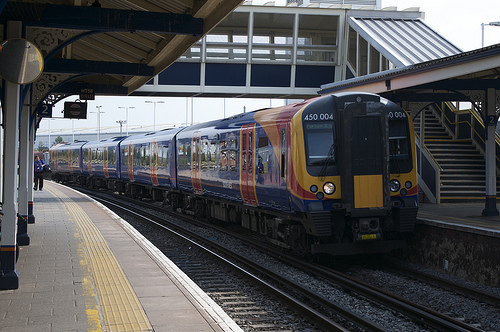What is the function of the structure seen at coordinates [0.3, 0.18, 0.88, 0.36]? The structure within these coordinates is a catwalk situated over the train tracks. It's utilized for maintenance or emergency purposes, providing essential access across the tracks without disrupting train operations. 